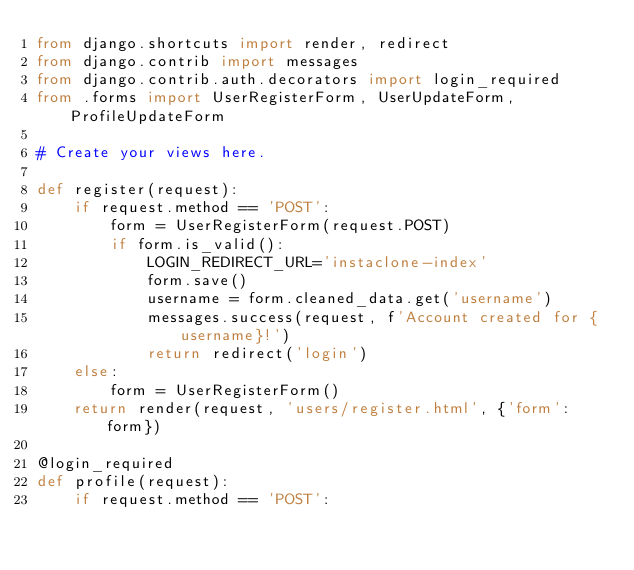<code> <loc_0><loc_0><loc_500><loc_500><_Python_>from django.shortcuts import render, redirect
from django.contrib import messages
from django.contrib.auth.decorators import login_required
from .forms import UserRegisterForm, UserUpdateForm, ProfileUpdateForm 

# Create your views here.

def register(request):
    if request.method == 'POST':
        form = UserRegisterForm(request.POST)
        if form.is_valid():
            LOGIN_REDIRECT_URL='instaclone-index'
            form.save()
            username = form.cleaned_data.get('username')
            messages.success(request, f'Account created for {username}!')
            return redirect('login')
    else:
        form = UserRegisterForm()
    return render(request, 'users/register.html', {'form': form})

@login_required
def profile(request):
    if request.method == 'POST':</code> 